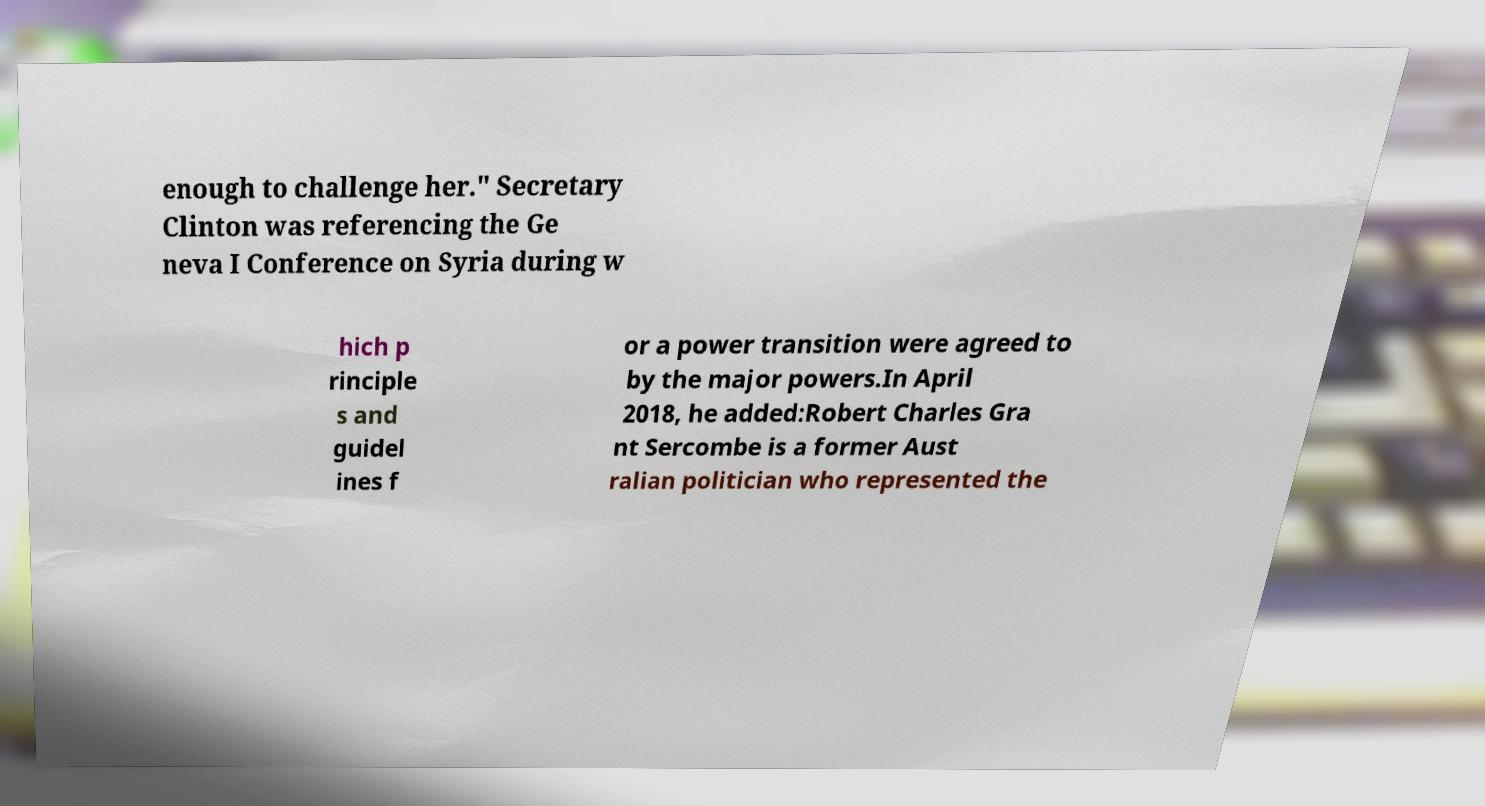Please read and relay the text visible in this image. What does it say? enough to challenge her." Secretary Clinton was referencing the Ge neva I Conference on Syria during w hich p rinciple s and guidel ines f or a power transition were agreed to by the major powers.In April 2018, he added:Robert Charles Gra nt Sercombe is a former Aust ralian politician who represented the 